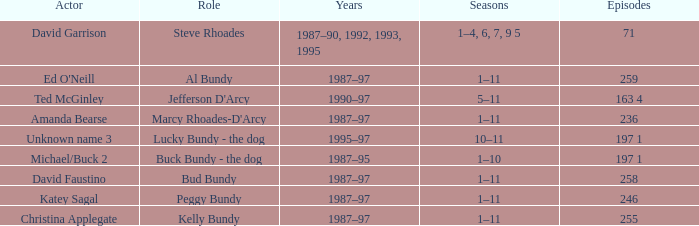How many years did the role of Steve Rhoades last? 1987–90, 1992, 1993, 1995. 